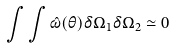Convert formula to latex. <formula><loc_0><loc_0><loc_500><loc_500>\int \int \hat { \omega } ( \theta ) \delta \Omega _ { 1 } \delta \Omega _ { 2 } \simeq 0</formula> 